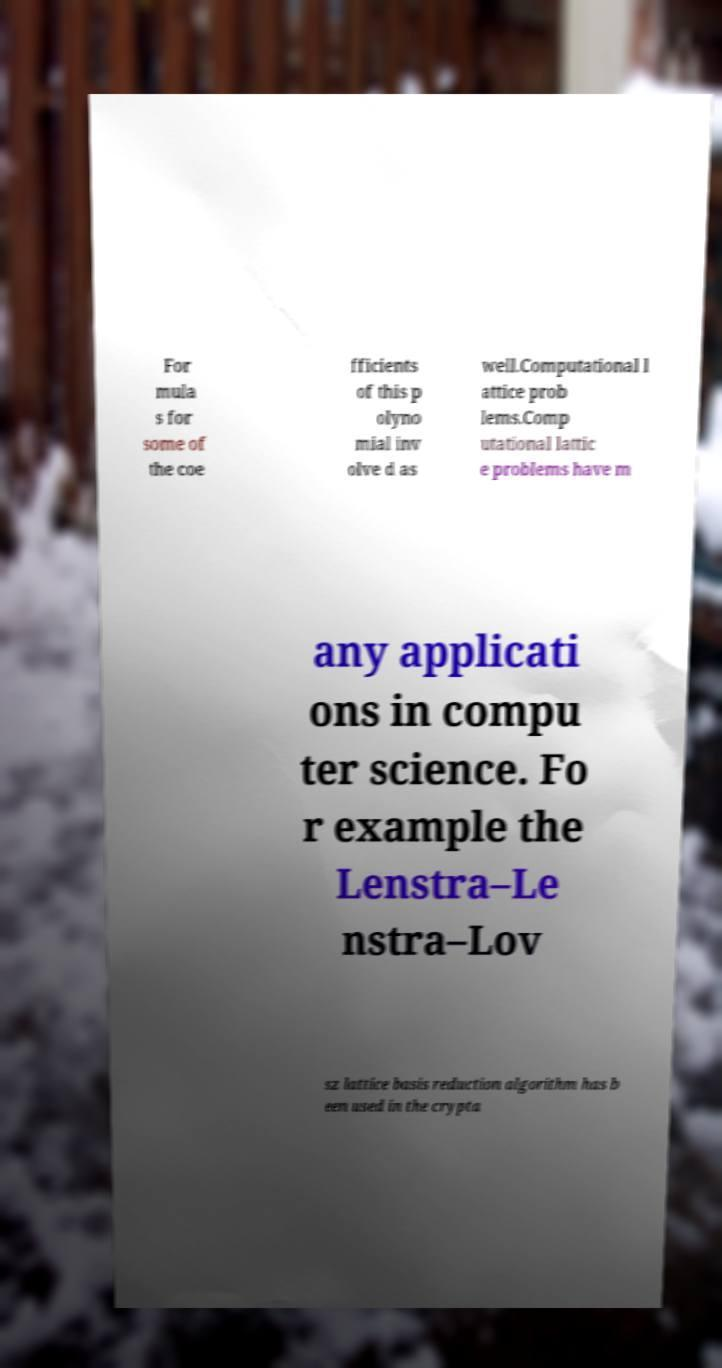I need the written content from this picture converted into text. Can you do that? For mula s for some of the coe fficients of this p olyno mial inv olve d as well.Computational l attice prob lems.Comp utational lattic e problems have m any applicati ons in compu ter science. Fo r example the Lenstra–Le nstra–Lov sz lattice basis reduction algorithm has b een used in the crypta 